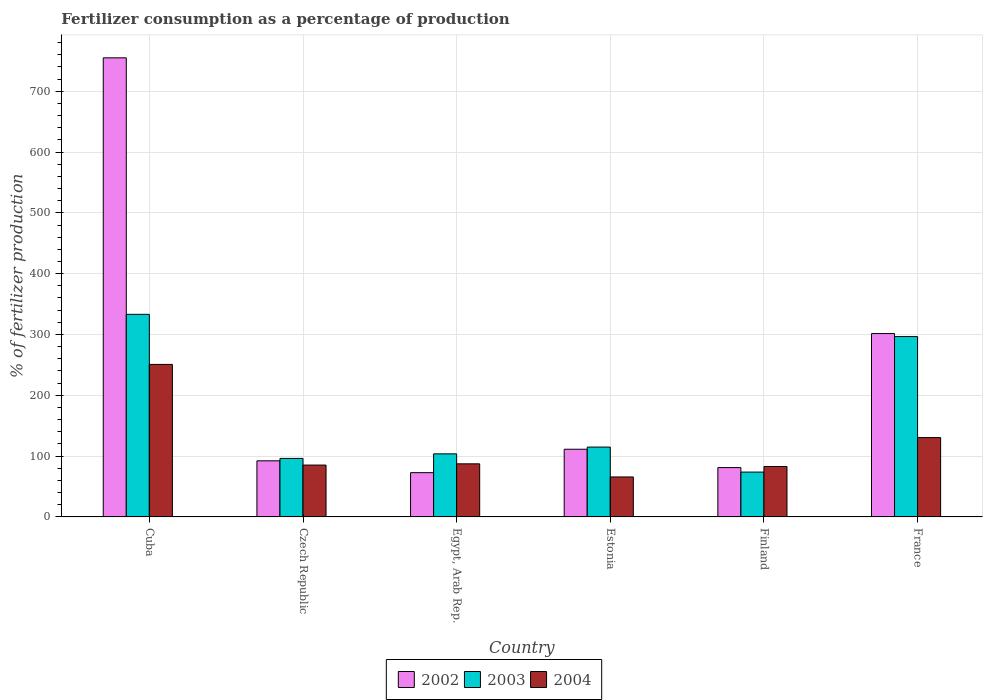How many different coloured bars are there?
Make the answer very short. 3. Are the number of bars per tick equal to the number of legend labels?
Provide a short and direct response. Yes. How many bars are there on the 6th tick from the left?
Provide a succinct answer. 3. What is the label of the 2nd group of bars from the left?
Ensure brevity in your answer.  Czech Republic. What is the percentage of fertilizers consumed in 2004 in Czech Republic?
Keep it short and to the point. 85.27. Across all countries, what is the maximum percentage of fertilizers consumed in 2004?
Offer a terse response. 250.78. Across all countries, what is the minimum percentage of fertilizers consumed in 2004?
Provide a short and direct response. 65.74. In which country was the percentage of fertilizers consumed in 2003 maximum?
Keep it short and to the point. Cuba. In which country was the percentage of fertilizers consumed in 2003 minimum?
Make the answer very short. Finland. What is the total percentage of fertilizers consumed in 2002 in the graph?
Offer a very short reply. 1413.93. What is the difference between the percentage of fertilizers consumed in 2004 in Czech Republic and that in Finland?
Your answer should be very brief. 2.34. What is the difference between the percentage of fertilizers consumed in 2004 in France and the percentage of fertilizers consumed in 2002 in Czech Republic?
Provide a short and direct response. 38.2. What is the average percentage of fertilizers consumed in 2004 per country?
Give a very brief answer. 117.08. What is the difference between the percentage of fertilizers consumed of/in 2002 and percentage of fertilizers consumed of/in 2003 in Czech Republic?
Make the answer very short. -3.96. What is the ratio of the percentage of fertilizers consumed in 2002 in Cuba to that in Egypt, Arab Rep.?
Give a very brief answer. 10.37. Is the percentage of fertilizers consumed in 2004 in Egypt, Arab Rep. less than that in Finland?
Give a very brief answer. No. What is the difference between the highest and the second highest percentage of fertilizers consumed in 2004?
Make the answer very short. 163.48. What is the difference between the highest and the lowest percentage of fertilizers consumed in 2002?
Make the answer very short. 682.1. In how many countries, is the percentage of fertilizers consumed in 2003 greater than the average percentage of fertilizers consumed in 2003 taken over all countries?
Your answer should be compact. 2. What does the 1st bar from the left in Czech Republic represents?
Your answer should be compact. 2002. How many bars are there?
Keep it short and to the point. 18. Are all the bars in the graph horizontal?
Keep it short and to the point. No. What is the difference between two consecutive major ticks on the Y-axis?
Your answer should be very brief. 100. Does the graph contain any zero values?
Provide a succinct answer. No. Does the graph contain grids?
Provide a succinct answer. Yes. Where does the legend appear in the graph?
Offer a very short reply. Bottom center. How many legend labels are there?
Offer a terse response. 3. How are the legend labels stacked?
Your response must be concise. Horizontal. What is the title of the graph?
Give a very brief answer. Fertilizer consumption as a percentage of production. What is the label or title of the Y-axis?
Your answer should be compact. % of fertilizer production. What is the % of fertilizer production in 2002 in Cuba?
Make the answer very short. 754.9. What is the % of fertilizer production of 2003 in Cuba?
Provide a short and direct response. 333.13. What is the % of fertilizer production in 2004 in Cuba?
Offer a very short reply. 250.78. What is the % of fertilizer production of 2002 in Czech Republic?
Ensure brevity in your answer.  92.26. What is the % of fertilizer production of 2003 in Czech Republic?
Give a very brief answer. 96.22. What is the % of fertilizer production in 2004 in Czech Republic?
Keep it short and to the point. 85.27. What is the % of fertilizer production of 2002 in Egypt, Arab Rep.?
Keep it short and to the point. 72.8. What is the % of fertilizer production of 2003 in Egypt, Arab Rep.?
Provide a short and direct response. 103.72. What is the % of fertilizer production of 2004 in Egypt, Arab Rep.?
Your answer should be compact. 87.3. What is the % of fertilizer production in 2002 in Estonia?
Offer a terse response. 111.3. What is the % of fertilizer production of 2003 in Estonia?
Offer a very short reply. 114.85. What is the % of fertilizer production in 2004 in Estonia?
Make the answer very short. 65.74. What is the % of fertilizer production in 2002 in Finland?
Your answer should be compact. 81.14. What is the % of fertilizer production of 2003 in Finland?
Provide a succinct answer. 73.73. What is the % of fertilizer production in 2004 in Finland?
Your response must be concise. 82.93. What is the % of fertilizer production in 2002 in France?
Offer a very short reply. 301.53. What is the % of fertilizer production in 2003 in France?
Provide a succinct answer. 296.56. What is the % of fertilizer production in 2004 in France?
Your answer should be very brief. 130.46. Across all countries, what is the maximum % of fertilizer production of 2002?
Make the answer very short. 754.9. Across all countries, what is the maximum % of fertilizer production in 2003?
Ensure brevity in your answer.  333.13. Across all countries, what is the maximum % of fertilizer production in 2004?
Keep it short and to the point. 250.78. Across all countries, what is the minimum % of fertilizer production of 2002?
Offer a very short reply. 72.8. Across all countries, what is the minimum % of fertilizer production in 2003?
Your response must be concise. 73.73. Across all countries, what is the minimum % of fertilizer production of 2004?
Give a very brief answer. 65.74. What is the total % of fertilizer production of 2002 in the graph?
Your response must be concise. 1413.93. What is the total % of fertilizer production of 2003 in the graph?
Provide a succinct answer. 1018.21. What is the total % of fertilizer production of 2004 in the graph?
Give a very brief answer. 702.47. What is the difference between the % of fertilizer production in 2002 in Cuba and that in Czech Republic?
Provide a short and direct response. 662.64. What is the difference between the % of fertilizer production in 2003 in Cuba and that in Czech Republic?
Offer a very short reply. 236.9. What is the difference between the % of fertilizer production in 2004 in Cuba and that in Czech Republic?
Your response must be concise. 165.51. What is the difference between the % of fertilizer production in 2002 in Cuba and that in Egypt, Arab Rep.?
Provide a succinct answer. 682.1. What is the difference between the % of fertilizer production in 2003 in Cuba and that in Egypt, Arab Rep.?
Offer a very short reply. 229.41. What is the difference between the % of fertilizer production of 2004 in Cuba and that in Egypt, Arab Rep.?
Provide a short and direct response. 163.48. What is the difference between the % of fertilizer production in 2002 in Cuba and that in Estonia?
Make the answer very short. 643.6. What is the difference between the % of fertilizer production in 2003 in Cuba and that in Estonia?
Your response must be concise. 218.28. What is the difference between the % of fertilizer production of 2004 in Cuba and that in Estonia?
Give a very brief answer. 185.04. What is the difference between the % of fertilizer production of 2002 in Cuba and that in Finland?
Provide a short and direct response. 673.76. What is the difference between the % of fertilizer production of 2003 in Cuba and that in Finland?
Make the answer very short. 259.39. What is the difference between the % of fertilizer production in 2004 in Cuba and that in Finland?
Offer a very short reply. 167.85. What is the difference between the % of fertilizer production of 2002 in Cuba and that in France?
Offer a terse response. 453.37. What is the difference between the % of fertilizer production of 2003 in Cuba and that in France?
Ensure brevity in your answer.  36.56. What is the difference between the % of fertilizer production of 2004 in Cuba and that in France?
Your response must be concise. 120.32. What is the difference between the % of fertilizer production in 2002 in Czech Republic and that in Egypt, Arab Rep.?
Provide a succinct answer. 19.47. What is the difference between the % of fertilizer production of 2003 in Czech Republic and that in Egypt, Arab Rep.?
Ensure brevity in your answer.  -7.5. What is the difference between the % of fertilizer production of 2004 in Czech Republic and that in Egypt, Arab Rep.?
Give a very brief answer. -2.03. What is the difference between the % of fertilizer production in 2002 in Czech Republic and that in Estonia?
Your answer should be compact. -19.04. What is the difference between the % of fertilizer production in 2003 in Czech Republic and that in Estonia?
Your answer should be very brief. -18.63. What is the difference between the % of fertilizer production of 2004 in Czech Republic and that in Estonia?
Your response must be concise. 19.53. What is the difference between the % of fertilizer production in 2002 in Czech Republic and that in Finland?
Ensure brevity in your answer.  11.12. What is the difference between the % of fertilizer production of 2003 in Czech Republic and that in Finland?
Ensure brevity in your answer.  22.49. What is the difference between the % of fertilizer production of 2004 in Czech Republic and that in Finland?
Ensure brevity in your answer.  2.34. What is the difference between the % of fertilizer production in 2002 in Czech Republic and that in France?
Give a very brief answer. -209.27. What is the difference between the % of fertilizer production in 2003 in Czech Republic and that in France?
Your answer should be very brief. -200.34. What is the difference between the % of fertilizer production in 2004 in Czech Republic and that in France?
Keep it short and to the point. -45.19. What is the difference between the % of fertilizer production in 2002 in Egypt, Arab Rep. and that in Estonia?
Make the answer very short. -38.51. What is the difference between the % of fertilizer production in 2003 in Egypt, Arab Rep. and that in Estonia?
Provide a short and direct response. -11.13. What is the difference between the % of fertilizer production of 2004 in Egypt, Arab Rep. and that in Estonia?
Offer a terse response. 21.56. What is the difference between the % of fertilizer production in 2002 in Egypt, Arab Rep. and that in Finland?
Provide a succinct answer. -8.34. What is the difference between the % of fertilizer production of 2003 in Egypt, Arab Rep. and that in Finland?
Your answer should be very brief. 29.99. What is the difference between the % of fertilizer production in 2004 in Egypt, Arab Rep. and that in Finland?
Keep it short and to the point. 4.37. What is the difference between the % of fertilizer production of 2002 in Egypt, Arab Rep. and that in France?
Ensure brevity in your answer.  -228.73. What is the difference between the % of fertilizer production of 2003 in Egypt, Arab Rep. and that in France?
Give a very brief answer. -192.85. What is the difference between the % of fertilizer production of 2004 in Egypt, Arab Rep. and that in France?
Your answer should be very brief. -43.16. What is the difference between the % of fertilizer production of 2002 in Estonia and that in Finland?
Ensure brevity in your answer.  30.17. What is the difference between the % of fertilizer production of 2003 in Estonia and that in Finland?
Offer a very short reply. 41.12. What is the difference between the % of fertilizer production in 2004 in Estonia and that in Finland?
Your response must be concise. -17.19. What is the difference between the % of fertilizer production of 2002 in Estonia and that in France?
Your answer should be compact. -190.22. What is the difference between the % of fertilizer production of 2003 in Estonia and that in France?
Keep it short and to the point. -181.71. What is the difference between the % of fertilizer production in 2004 in Estonia and that in France?
Your answer should be compact. -64.72. What is the difference between the % of fertilizer production of 2002 in Finland and that in France?
Ensure brevity in your answer.  -220.39. What is the difference between the % of fertilizer production of 2003 in Finland and that in France?
Your response must be concise. -222.83. What is the difference between the % of fertilizer production of 2004 in Finland and that in France?
Your answer should be compact. -47.53. What is the difference between the % of fertilizer production of 2002 in Cuba and the % of fertilizer production of 2003 in Czech Republic?
Keep it short and to the point. 658.68. What is the difference between the % of fertilizer production of 2002 in Cuba and the % of fertilizer production of 2004 in Czech Republic?
Provide a succinct answer. 669.63. What is the difference between the % of fertilizer production of 2003 in Cuba and the % of fertilizer production of 2004 in Czech Republic?
Provide a short and direct response. 247.86. What is the difference between the % of fertilizer production in 2002 in Cuba and the % of fertilizer production in 2003 in Egypt, Arab Rep.?
Provide a short and direct response. 651.18. What is the difference between the % of fertilizer production in 2002 in Cuba and the % of fertilizer production in 2004 in Egypt, Arab Rep.?
Give a very brief answer. 667.6. What is the difference between the % of fertilizer production in 2003 in Cuba and the % of fertilizer production in 2004 in Egypt, Arab Rep.?
Provide a short and direct response. 245.83. What is the difference between the % of fertilizer production in 2002 in Cuba and the % of fertilizer production in 2003 in Estonia?
Keep it short and to the point. 640.05. What is the difference between the % of fertilizer production of 2002 in Cuba and the % of fertilizer production of 2004 in Estonia?
Your answer should be very brief. 689.16. What is the difference between the % of fertilizer production in 2003 in Cuba and the % of fertilizer production in 2004 in Estonia?
Offer a very short reply. 267.39. What is the difference between the % of fertilizer production of 2002 in Cuba and the % of fertilizer production of 2003 in Finland?
Keep it short and to the point. 681.17. What is the difference between the % of fertilizer production in 2002 in Cuba and the % of fertilizer production in 2004 in Finland?
Give a very brief answer. 671.97. What is the difference between the % of fertilizer production in 2003 in Cuba and the % of fertilizer production in 2004 in Finland?
Your answer should be compact. 250.19. What is the difference between the % of fertilizer production in 2002 in Cuba and the % of fertilizer production in 2003 in France?
Make the answer very short. 458.34. What is the difference between the % of fertilizer production in 2002 in Cuba and the % of fertilizer production in 2004 in France?
Keep it short and to the point. 624.44. What is the difference between the % of fertilizer production of 2003 in Cuba and the % of fertilizer production of 2004 in France?
Your answer should be very brief. 202.67. What is the difference between the % of fertilizer production in 2002 in Czech Republic and the % of fertilizer production in 2003 in Egypt, Arab Rep.?
Your answer should be very brief. -11.46. What is the difference between the % of fertilizer production in 2002 in Czech Republic and the % of fertilizer production in 2004 in Egypt, Arab Rep.?
Provide a short and direct response. 4.96. What is the difference between the % of fertilizer production of 2003 in Czech Republic and the % of fertilizer production of 2004 in Egypt, Arab Rep.?
Provide a succinct answer. 8.92. What is the difference between the % of fertilizer production of 2002 in Czech Republic and the % of fertilizer production of 2003 in Estonia?
Your answer should be very brief. -22.59. What is the difference between the % of fertilizer production in 2002 in Czech Republic and the % of fertilizer production in 2004 in Estonia?
Provide a succinct answer. 26.52. What is the difference between the % of fertilizer production of 2003 in Czech Republic and the % of fertilizer production of 2004 in Estonia?
Keep it short and to the point. 30.48. What is the difference between the % of fertilizer production of 2002 in Czech Republic and the % of fertilizer production of 2003 in Finland?
Your answer should be compact. 18.53. What is the difference between the % of fertilizer production in 2002 in Czech Republic and the % of fertilizer production in 2004 in Finland?
Your answer should be very brief. 9.33. What is the difference between the % of fertilizer production of 2003 in Czech Republic and the % of fertilizer production of 2004 in Finland?
Provide a succinct answer. 13.29. What is the difference between the % of fertilizer production in 2002 in Czech Republic and the % of fertilizer production in 2003 in France?
Ensure brevity in your answer.  -204.3. What is the difference between the % of fertilizer production of 2002 in Czech Republic and the % of fertilizer production of 2004 in France?
Make the answer very short. -38.2. What is the difference between the % of fertilizer production of 2003 in Czech Republic and the % of fertilizer production of 2004 in France?
Make the answer very short. -34.24. What is the difference between the % of fertilizer production of 2002 in Egypt, Arab Rep. and the % of fertilizer production of 2003 in Estonia?
Your response must be concise. -42.05. What is the difference between the % of fertilizer production in 2002 in Egypt, Arab Rep. and the % of fertilizer production in 2004 in Estonia?
Ensure brevity in your answer.  7.06. What is the difference between the % of fertilizer production in 2003 in Egypt, Arab Rep. and the % of fertilizer production in 2004 in Estonia?
Make the answer very short. 37.98. What is the difference between the % of fertilizer production of 2002 in Egypt, Arab Rep. and the % of fertilizer production of 2003 in Finland?
Keep it short and to the point. -0.94. What is the difference between the % of fertilizer production in 2002 in Egypt, Arab Rep. and the % of fertilizer production in 2004 in Finland?
Offer a terse response. -10.14. What is the difference between the % of fertilizer production of 2003 in Egypt, Arab Rep. and the % of fertilizer production of 2004 in Finland?
Give a very brief answer. 20.79. What is the difference between the % of fertilizer production of 2002 in Egypt, Arab Rep. and the % of fertilizer production of 2003 in France?
Offer a terse response. -223.77. What is the difference between the % of fertilizer production of 2002 in Egypt, Arab Rep. and the % of fertilizer production of 2004 in France?
Your response must be concise. -57.66. What is the difference between the % of fertilizer production in 2003 in Egypt, Arab Rep. and the % of fertilizer production in 2004 in France?
Offer a very short reply. -26.74. What is the difference between the % of fertilizer production of 2002 in Estonia and the % of fertilizer production of 2003 in Finland?
Provide a short and direct response. 37.57. What is the difference between the % of fertilizer production in 2002 in Estonia and the % of fertilizer production in 2004 in Finland?
Give a very brief answer. 28.37. What is the difference between the % of fertilizer production of 2003 in Estonia and the % of fertilizer production of 2004 in Finland?
Offer a terse response. 31.92. What is the difference between the % of fertilizer production of 2002 in Estonia and the % of fertilizer production of 2003 in France?
Offer a terse response. -185.26. What is the difference between the % of fertilizer production of 2002 in Estonia and the % of fertilizer production of 2004 in France?
Offer a terse response. -19.16. What is the difference between the % of fertilizer production of 2003 in Estonia and the % of fertilizer production of 2004 in France?
Offer a very short reply. -15.61. What is the difference between the % of fertilizer production in 2002 in Finland and the % of fertilizer production in 2003 in France?
Ensure brevity in your answer.  -215.43. What is the difference between the % of fertilizer production of 2002 in Finland and the % of fertilizer production of 2004 in France?
Ensure brevity in your answer.  -49.32. What is the difference between the % of fertilizer production of 2003 in Finland and the % of fertilizer production of 2004 in France?
Make the answer very short. -56.73. What is the average % of fertilizer production of 2002 per country?
Your response must be concise. 235.65. What is the average % of fertilizer production in 2003 per country?
Keep it short and to the point. 169.7. What is the average % of fertilizer production in 2004 per country?
Keep it short and to the point. 117.08. What is the difference between the % of fertilizer production in 2002 and % of fertilizer production in 2003 in Cuba?
Offer a very short reply. 421.78. What is the difference between the % of fertilizer production in 2002 and % of fertilizer production in 2004 in Cuba?
Provide a short and direct response. 504.12. What is the difference between the % of fertilizer production in 2003 and % of fertilizer production in 2004 in Cuba?
Your answer should be compact. 82.35. What is the difference between the % of fertilizer production of 2002 and % of fertilizer production of 2003 in Czech Republic?
Make the answer very short. -3.96. What is the difference between the % of fertilizer production in 2002 and % of fertilizer production in 2004 in Czech Republic?
Provide a short and direct response. 6.99. What is the difference between the % of fertilizer production in 2003 and % of fertilizer production in 2004 in Czech Republic?
Give a very brief answer. 10.95. What is the difference between the % of fertilizer production in 2002 and % of fertilizer production in 2003 in Egypt, Arab Rep.?
Your answer should be compact. -30.92. What is the difference between the % of fertilizer production in 2002 and % of fertilizer production in 2004 in Egypt, Arab Rep.?
Make the answer very short. -14.5. What is the difference between the % of fertilizer production of 2003 and % of fertilizer production of 2004 in Egypt, Arab Rep.?
Give a very brief answer. 16.42. What is the difference between the % of fertilizer production of 2002 and % of fertilizer production of 2003 in Estonia?
Give a very brief answer. -3.55. What is the difference between the % of fertilizer production in 2002 and % of fertilizer production in 2004 in Estonia?
Ensure brevity in your answer.  45.57. What is the difference between the % of fertilizer production of 2003 and % of fertilizer production of 2004 in Estonia?
Make the answer very short. 49.11. What is the difference between the % of fertilizer production of 2002 and % of fertilizer production of 2003 in Finland?
Provide a succinct answer. 7.41. What is the difference between the % of fertilizer production of 2002 and % of fertilizer production of 2004 in Finland?
Keep it short and to the point. -1.79. What is the difference between the % of fertilizer production in 2003 and % of fertilizer production in 2004 in Finland?
Your answer should be compact. -9.2. What is the difference between the % of fertilizer production in 2002 and % of fertilizer production in 2003 in France?
Offer a very short reply. 4.96. What is the difference between the % of fertilizer production of 2002 and % of fertilizer production of 2004 in France?
Provide a short and direct response. 171.07. What is the difference between the % of fertilizer production in 2003 and % of fertilizer production in 2004 in France?
Provide a succinct answer. 166.1. What is the ratio of the % of fertilizer production in 2002 in Cuba to that in Czech Republic?
Keep it short and to the point. 8.18. What is the ratio of the % of fertilizer production of 2003 in Cuba to that in Czech Republic?
Offer a terse response. 3.46. What is the ratio of the % of fertilizer production in 2004 in Cuba to that in Czech Republic?
Make the answer very short. 2.94. What is the ratio of the % of fertilizer production of 2002 in Cuba to that in Egypt, Arab Rep.?
Make the answer very short. 10.37. What is the ratio of the % of fertilizer production of 2003 in Cuba to that in Egypt, Arab Rep.?
Provide a succinct answer. 3.21. What is the ratio of the % of fertilizer production of 2004 in Cuba to that in Egypt, Arab Rep.?
Provide a succinct answer. 2.87. What is the ratio of the % of fertilizer production of 2002 in Cuba to that in Estonia?
Your answer should be very brief. 6.78. What is the ratio of the % of fertilizer production of 2003 in Cuba to that in Estonia?
Your answer should be very brief. 2.9. What is the ratio of the % of fertilizer production in 2004 in Cuba to that in Estonia?
Offer a very short reply. 3.81. What is the ratio of the % of fertilizer production of 2002 in Cuba to that in Finland?
Your answer should be very brief. 9.3. What is the ratio of the % of fertilizer production in 2003 in Cuba to that in Finland?
Offer a terse response. 4.52. What is the ratio of the % of fertilizer production in 2004 in Cuba to that in Finland?
Give a very brief answer. 3.02. What is the ratio of the % of fertilizer production of 2002 in Cuba to that in France?
Keep it short and to the point. 2.5. What is the ratio of the % of fertilizer production in 2003 in Cuba to that in France?
Provide a succinct answer. 1.12. What is the ratio of the % of fertilizer production of 2004 in Cuba to that in France?
Ensure brevity in your answer.  1.92. What is the ratio of the % of fertilizer production in 2002 in Czech Republic to that in Egypt, Arab Rep.?
Keep it short and to the point. 1.27. What is the ratio of the % of fertilizer production of 2003 in Czech Republic to that in Egypt, Arab Rep.?
Keep it short and to the point. 0.93. What is the ratio of the % of fertilizer production of 2004 in Czech Republic to that in Egypt, Arab Rep.?
Provide a short and direct response. 0.98. What is the ratio of the % of fertilizer production in 2002 in Czech Republic to that in Estonia?
Make the answer very short. 0.83. What is the ratio of the % of fertilizer production in 2003 in Czech Republic to that in Estonia?
Provide a succinct answer. 0.84. What is the ratio of the % of fertilizer production of 2004 in Czech Republic to that in Estonia?
Offer a very short reply. 1.3. What is the ratio of the % of fertilizer production in 2002 in Czech Republic to that in Finland?
Provide a short and direct response. 1.14. What is the ratio of the % of fertilizer production in 2003 in Czech Republic to that in Finland?
Offer a terse response. 1.3. What is the ratio of the % of fertilizer production of 2004 in Czech Republic to that in Finland?
Offer a terse response. 1.03. What is the ratio of the % of fertilizer production in 2002 in Czech Republic to that in France?
Your answer should be very brief. 0.31. What is the ratio of the % of fertilizer production of 2003 in Czech Republic to that in France?
Make the answer very short. 0.32. What is the ratio of the % of fertilizer production in 2004 in Czech Republic to that in France?
Provide a succinct answer. 0.65. What is the ratio of the % of fertilizer production of 2002 in Egypt, Arab Rep. to that in Estonia?
Your answer should be very brief. 0.65. What is the ratio of the % of fertilizer production in 2003 in Egypt, Arab Rep. to that in Estonia?
Offer a very short reply. 0.9. What is the ratio of the % of fertilizer production in 2004 in Egypt, Arab Rep. to that in Estonia?
Your response must be concise. 1.33. What is the ratio of the % of fertilizer production in 2002 in Egypt, Arab Rep. to that in Finland?
Provide a succinct answer. 0.9. What is the ratio of the % of fertilizer production of 2003 in Egypt, Arab Rep. to that in Finland?
Give a very brief answer. 1.41. What is the ratio of the % of fertilizer production in 2004 in Egypt, Arab Rep. to that in Finland?
Give a very brief answer. 1.05. What is the ratio of the % of fertilizer production in 2002 in Egypt, Arab Rep. to that in France?
Make the answer very short. 0.24. What is the ratio of the % of fertilizer production in 2003 in Egypt, Arab Rep. to that in France?
Your answer should be very brief. 0.35. What is the ratio of the % of fertilizer production in 2004 in Egypt, Arab Rep. to that in France?
Ensure brevity in your answer.  0.67. What is the ratio of the % of fertilizer production of 2002 in Estonia to that in Finland?
Offer a very short reply. 1.37. What is the ratio of the % of fertilizer production of 2003 in Estonia to that in Finland?
Offer a terse response. 1.56. What is the ratio of the % of fertilizer production in 2004 in Estonia to that in Finland?
Ensure brevity in your answer.  0.79. What is the ratio of the % of fertilizer production in 2002 in Estonia to that in France?
Provide a short and direct response. 0.37. What is the ratio of the % of fertilizer production in 2003 in Estonia to that in France?
Give a very brief answer. 0.39. What is the ratio of the % of fertilizer production of 2004 in Estonia to that in France?
Your answer should be compact. 0.5. What is the ratio of the % of fertilizer production in 2002 in Finland to that in France?
Offer a very short reply. 0.27. What is the ratio of the % of fertilizer production in 2003 in Finland to that in France?
Ensure brevity in your answer.  0.25. What is the ratio of the % of fertilizer production of 2004 in Finland to that in France?
Offer a very short reply. 0.64. What is the difference between the highest and the second highest % of fertilizer production in 2002?
Keep it short and to the point. 453.37. What is the difference between the highest and the second highest % of fertilizer production of 2003?
Provide a succinct answer. 36.56. What is the difference between the highest and the second highest % of fertilizer production of 2004?
Make the answer very short. 120.32. What is the difference between the highest and the lowest % of fertilizer production in 2002?
Provide a short and direct response. 682.1. What is the difference between the highest and the lowest % of fertilizer production in 2003?
Make the answer very short. 259.39. What is the difference between the highest and the lowest % of fertilizer production of 2004?
Your response must be concise. 185.04. 